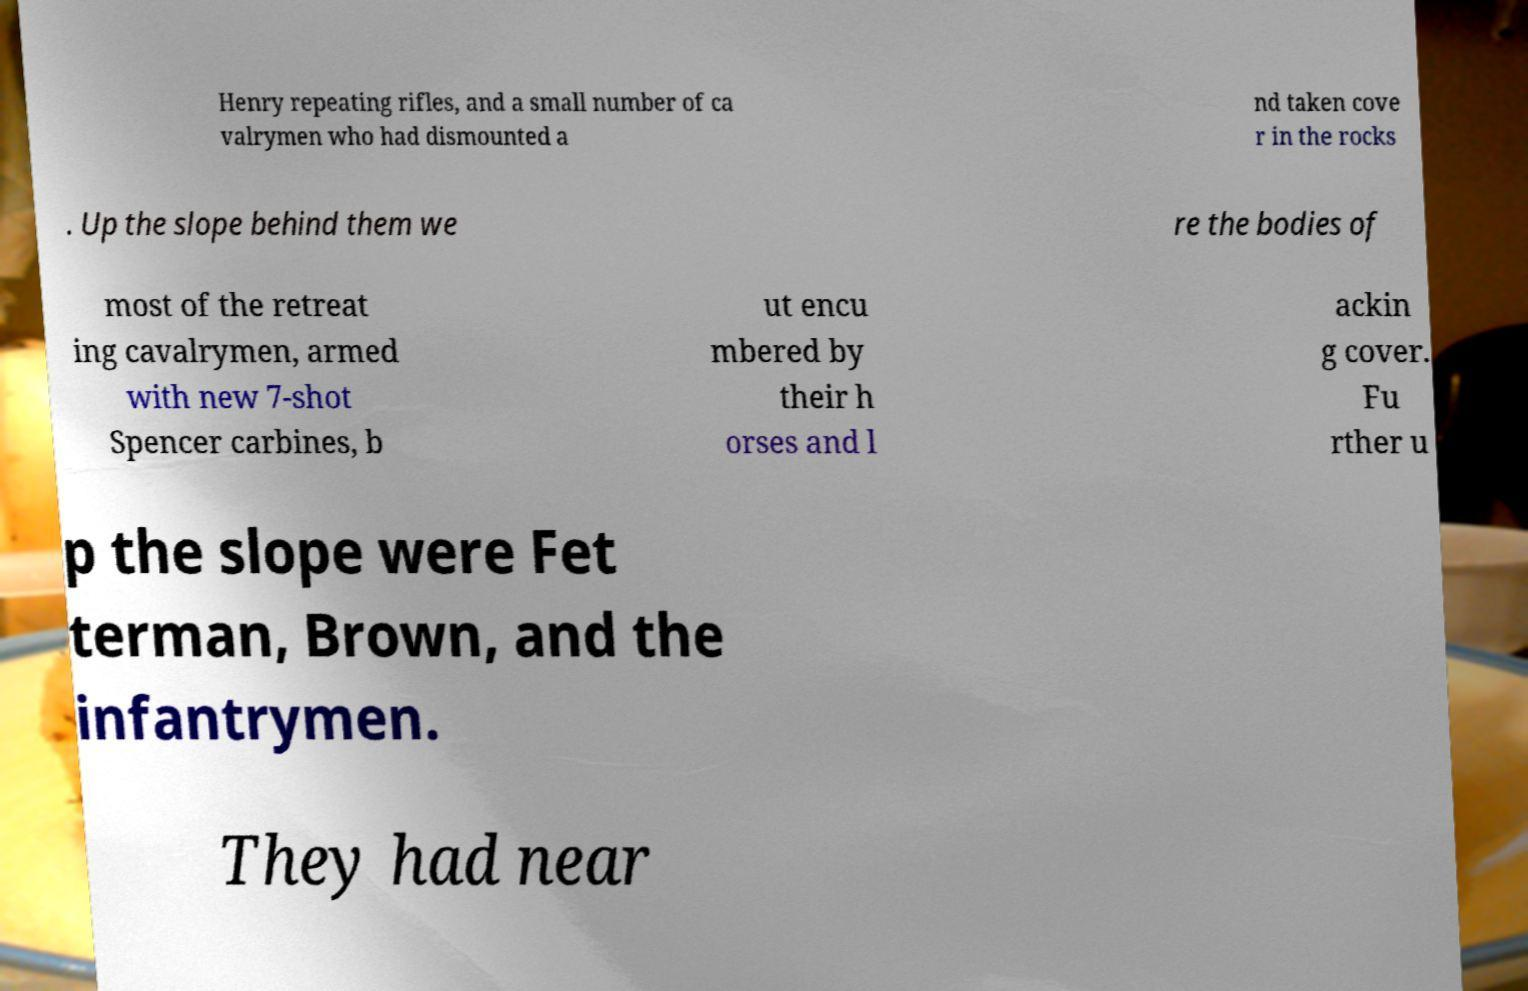I need the written content from this picture converted into text. Can you do that? Henry repeating rifles, and a small number of ca valrymen who had dismounted a nd taken cove r in the rocks . Up the slope behind them we re the bodies of most of the retreat ing cavalrymen, armed with new 7-shot Spencer carbines, b ut encu mbered by their h orses and l ackin g cover. Fu rther u p the slope were Fet terman, Brown, and the infantrymen. They had near 